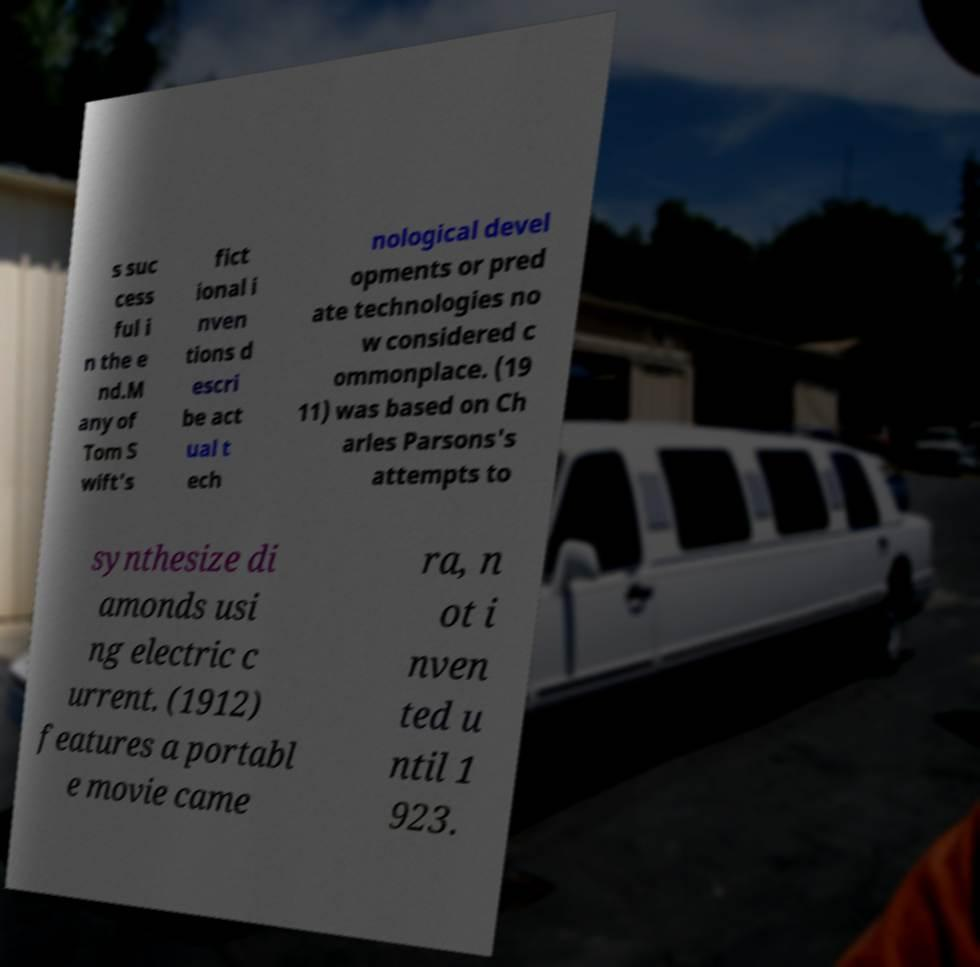There's text embedded in this image that I need extracted. Can you transcribe it verbatim? s suc cess ful i n the e nd.M any of Tom S wift's fict ional i nven tions d escri be act ual t ech nological devel opments or pred ate technologies no w considered c ommonplace. (19 11) was based on Ch arles Parsons's attempts to synthesize di amonds usi ng electric c urrent. (1912) features a portabl e movie came ra, n ot i nven ted u ntil 1 923. 